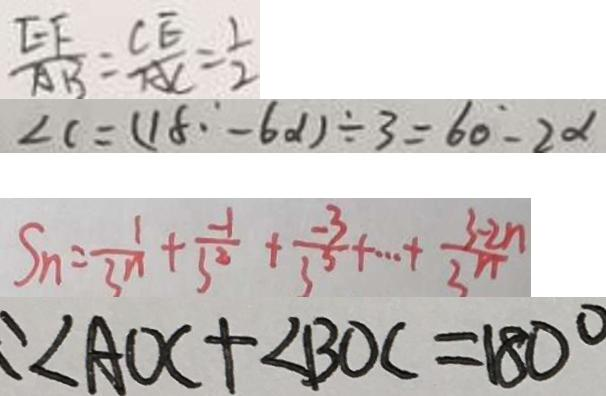<formula> <loc_0><loc_0><loc_500><loc_500>\frac { E F } { A B } = \frac { C E } { A C } = \frac { 1 } { 2 } 
 \angle C = ( 1 8 ^ { \circ } - 6 \alpha ) \div 3 = 6 0 - 2 \alpha 
 S _ { n } = \frac { 1 } { 3 ^ { n } } + \frac { - 1 } { 3 ^ { 2 } } + \frac { - 3 } { 3 ^ { 3 } } + \cdots + \frac { 3 - 2 n } { 3 ^ { n } } 
 : \angle A O C + \angle B O C = 1 8 0 ^ { \circ }</formula> 